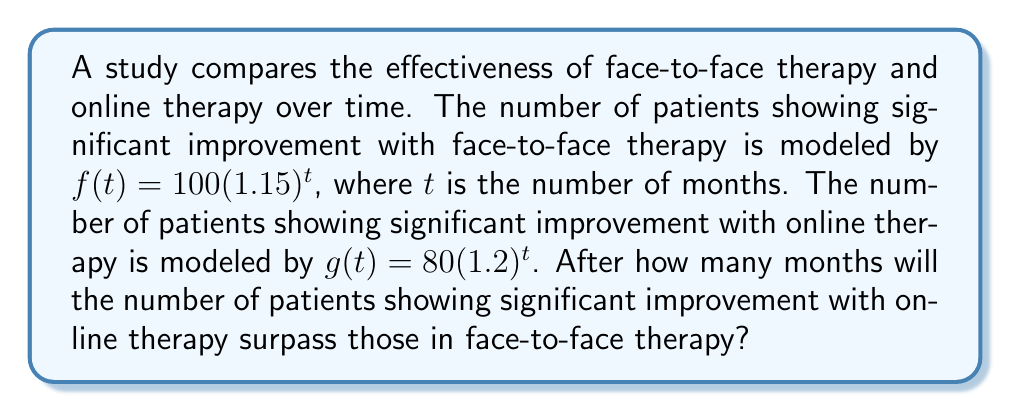Can you answer this question? To solve this problem, we need to find when $g(t)$ becomes greater than $f(t)$:

1) Set up the inequality:
   $g(t) > f(t)$
   $80(1.2)^t > 100(1.15)^t$

2) Divide both sides by 80:
   $(1.2)^t > \frac{100}{80}(1.15)^t$
   $(1.2)^t > 1.25(1.15)^t$

3) Take the natural log of both sides:
   $t \ln(1.2) > \ln(1.25) + t \ln(1.15)$

4) Subtract $t \ln(1.15)$ from both sides:
   $t(\ln(1.2) - \ln(1.15)) > \ln(1.25)$

5) Divide both sides by $(\ln(1.2) - \ln(1.15))$:
   $t > \frac{\ln(1.25)}{\ln(1.2) - \ln(1.15)}$

6) Calculate the right side:
   $t > \frac{\ln(1.25)}{\ln(1.2) - \ln(1.15)} \approx 11.43$

7) Since $t$ represents months, we need to round up to the next whole number.

Therefore, after 12 months, the number of patients showing significant improvement with online therapy will surpass those in face-to-face therapy.
Answer: 12 months 